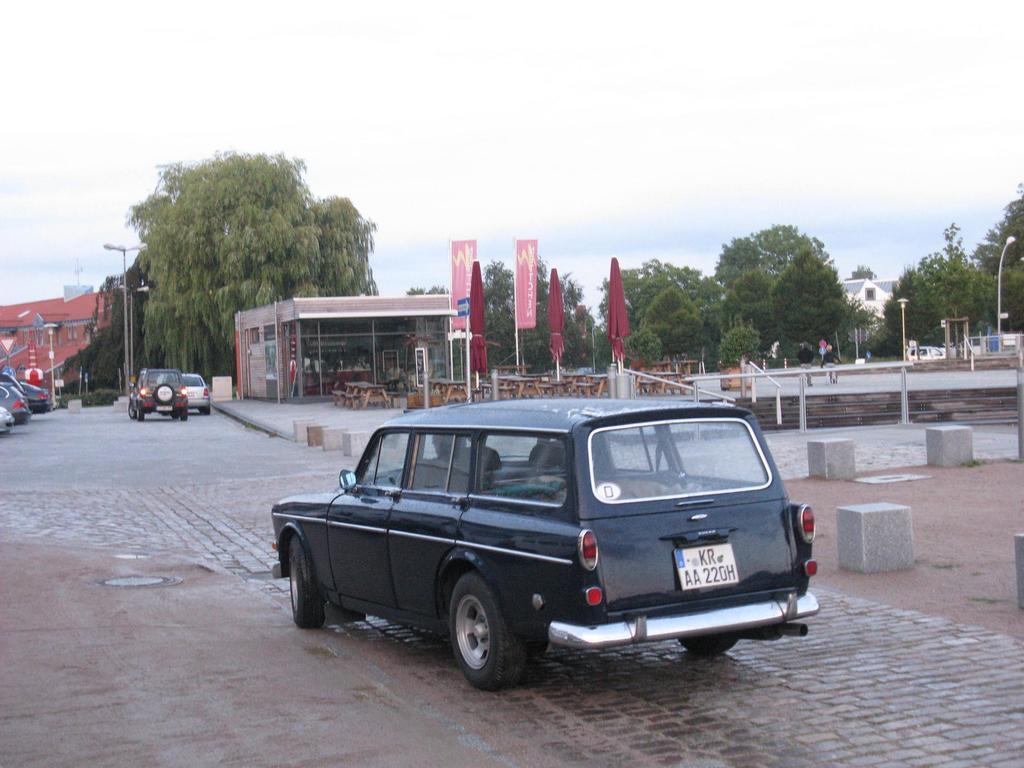How would you summarize this image in a sentence or two? In this image in the front there is a car which is black in colour moving on the road. In the background there are cars, buildings, trees, flags, poles and on the right side there are seats and the sky is cloudy. 